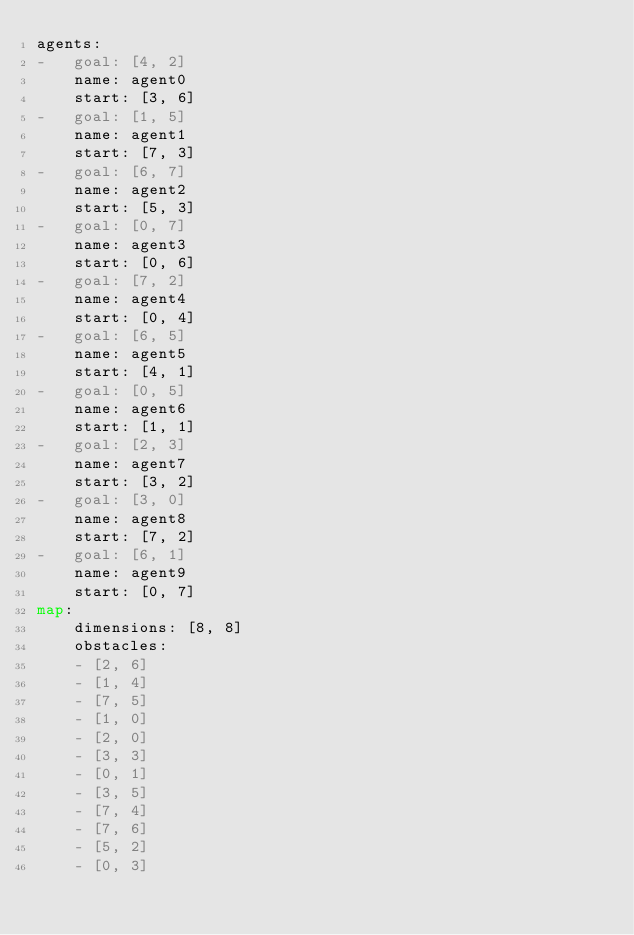<code> <loc_0><loc_0><loc_500><loc_500><_YAML_>agents:
-   goal: [4, 2]
    name: agent0
    start: [3, 6]
-   goal: [1, 5]
    name: agent1
    start: [7, 3]
-   goal: [6, 7]
    name: agent2
    start: [5, 3]
-   goal: [0, 7]
    name: agent3
    start: [0, 6]
-   goal: [7, 2]
    name: agent4
    start: [0, 4]
-   goal: [6, 5]
    name: agent5
    start: [4, 1]
-   goal: [0, 5]
    name: agent6
    start: [1, 1]
-   goal: [2, 3]
    name: agent7
    start: [3, 2]
-   goal: [3, 0]
    name: agent8
    start: [7, 2]
-   goal: [6, 1]
    name: agent9
    start: [0, 7]
map:
    dimensions: [8, 8]
    obstacles:
    - [2, 6]
    - [1, 4]
    - [7, 5]
    - [1, 0]
    - [2, 0]
    - [3, 3]
    - [0, 1]
    - [3, 5]
    - [7, 4]
    - [7, 6]
    - [5, 2]
    - [0, 3]
</code> 